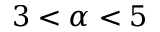<formula> <loc_0><loc_0><loc_500><loc_500>3 < \alpha < 5</formula> 